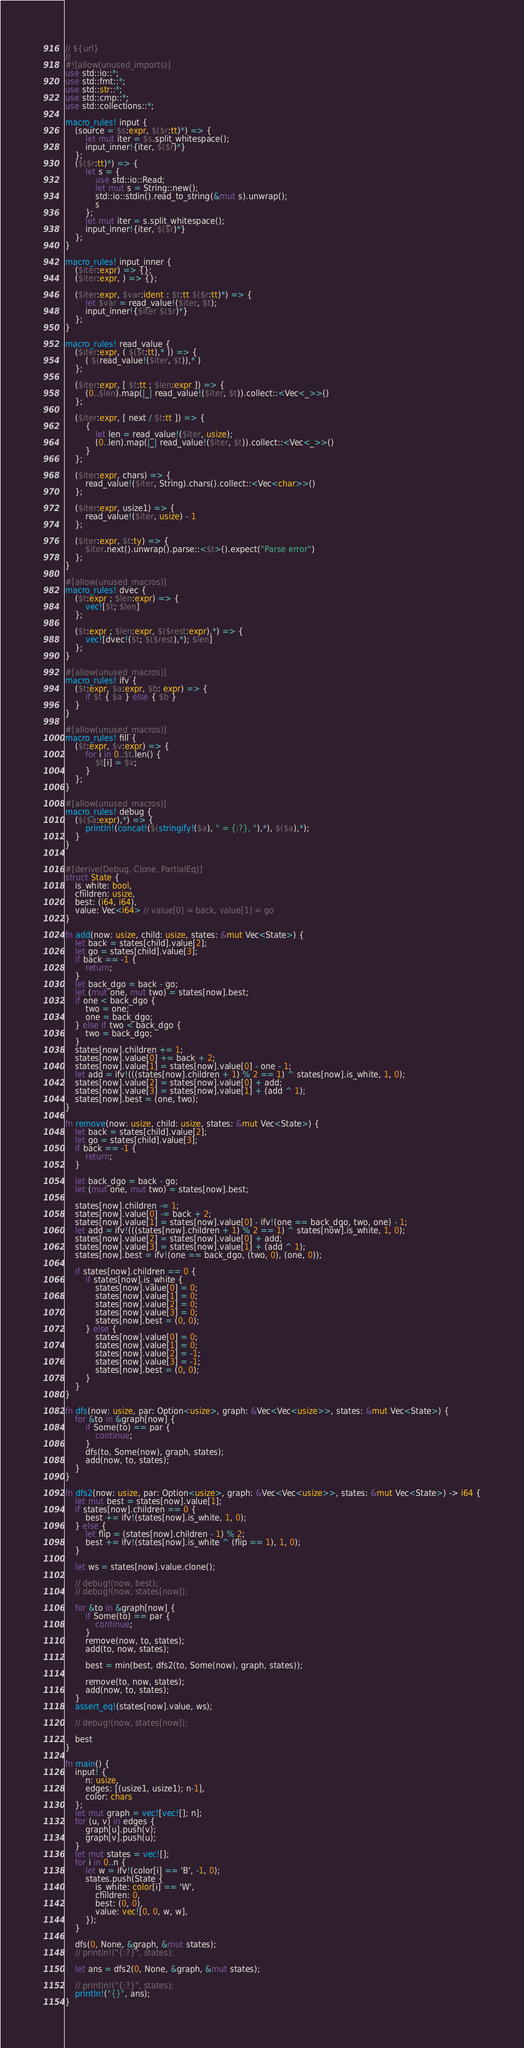<code> <loc_0><loc_0><loc_500><loc_500><_Rust_>// ${url}
//
#![allow(unused_imports)]
use std::io::*;
use std::fmt::*;
use std::str::*;
use std::cmp::*;
use std::collections::*;

macro_rules! input {
    (source = $s:expr, $($r:tt)*) => {
        let mut iter = $s.split_whitespace();
        input_inner!{iter, $($r)*}
    };
    ($($r:tt)*) => {
        let s = {
            use std::io::Read;
            let mut s = String::new();
            std::io::stdin().read_to_string(&mut s).unwrap();
            s
        };
        let mut iter = s.split_whitespace();
        input_inner!{iter, $($r)*}
    };
}

macro_rules! input_inner {
    ($iter:expr) => {};
    ($iter:expr, ) => {};

    ($iter:expr, $var:ident : $t:tt $($r:tt)*) => {
        let $var = read_value!($iter, $t);
        input_inner!{$iter $($r)*}
    };
}

macro_rules! read_value {
    ($iter:expr, ( $($t:tt),* )) => {
        ( $(read_value!($iter, $t)),* )
    };

    ($iter:expr, [ $t:tt ; $len:expr ]) => {
        (0..$len).map(|_| read_value!($iter, $t)).collect::<Vec<_>>()
    };

    ($iter:expr, [ next / $t:tt ]) => {
        {
            let len = read_value!($iter, usize);
            (0..len).map(|_| read_value!($iter, $t)).collect::<Vec<_>>()
        }
    };

    ($iter:expr, chars) => {
        read_value!($iter, String).chars().collect::<Vec<char>>()
    };

    ($iter:expr, usize1) => {
        read_value!($iter, usize) - 1
    };

    ($iter:expr, $t:ty) => {
        $iter.next().unwrap().parse::<$t>().expect("Parse error")
    };
}

#[allow(unused_macros)]
macro_rules! dvec {
    ($t:expr ; $len:expr) => {
        vec![$t; $len]
    };

    ($t:expr ; $len:expr, $($rest:expr),*) => {
        vec![dvec!($t; $($rest),*); $len]
    };
}

#[allow(unused_macros)]
macro_rules! ifv {
    ($t:expr, $a:expr, $b: expr) => {
        if $t { $a } else { $b }
    }
}

#[allow(unused_macros)]
macro_rules! fill {
    ($t:expr, $v:expr) => {
        for i in 0..$t.len() {
            $t[i] = $v;
        }
    };
}

#[allow(unused_macros)]
macro_rules! debug {
    ($($a:expr),*) => {
        println!(concat!($(stringify!($a), " = {:?}, "),*), $($a),*);
    }
}


#[derive(Debug, Clone, PartialEq)]
struct State {
    is_white: bool,
    children: usize,
    best: (i64, i64),
    value: Vec<i64> // value[0] = back, value[1] = go
}

fn add(now: usize, child: usize, states: &mut Vec<State>) {
    let back = states[child].value[2];
    let go = states[child].value[3];
    if back == -1 {
        return;
    }
    let back_dgo = back - go;
    let (mut one, mut two) = states[now].best;
    if one < back_dgo {
        two = one;
        one = back_dgo;
    } else if two < back_dgo {
        two = back_dgo;
    }
    states[now].children += 1;
    states[now].value[0] += back + 2;
    states[now].value[1] = states[now].value[0] - one - 1;
    let add = ifv!(((states[now].children + 1) % 2 == 1) ^ states[now].is_white, 1, 0);
    states[now].value[2] = states[now].value[0] + add;
    states[now].value[3] = states[now].value[1] + (add ^ 1);
    states[now].best = (one, two);
}

fn remove(now: usize, child: usize, states: &mut Vec<State>) {
    let back = states[child].value[2];
    let go = states[child].value[3];
    if back == -1 {
        return;
    }

    let back_dgo = back - go;
    let (mut one, mut two) = states[now].best;

    states[now].children -= 1;
    states[now].value[0] -= back + 2;
    states[now].value[1] = states[now].value[0] - ifv!(one == back_dgo, two, one) - 1;
    let add = ifv!(((states[now].children + 1) % 2 == 1) ^ states[now].is_white, 1, 0);
    states[now].value[2] = states[now].value[0] + add;
    states[now].value[3] = states[now].value[1] + (add ^ 1);
    states[now].best = ifv!(one == back_dgo, (two, 0), (one, 0));

    if states[now].children == 0 {
        if states[now].is_white {
            states[now].value[0] = 0;
            states[now].value[1] = 0;
            states[now].value[2] = 0;
            states[now].value[3] = 0;
            states[now].best = (0, 0);
        } else {
            states[now].value[0] = 0;
            states[now].value[1] = 0;
            states[now].value[2] = -1;
            states[now].value[3] = -1;
            states[now].best = (0, 0);
        }
    }
}

fn dfs(now: usize, par: Option<usize>, graph: &Vec<Vec<usize>>, states: &mut Vec<State>) {
    for &to in &graph[now] {
        if Some(to) == par {
            continue;
        }
        dfs(to, Some(now), graph, states);
        add(now, to, states);
    }
}

fn dfs2(now: usize, par: Option<usize>, graph: &Vec<Vec<usize>>, states: &mut Vec<State>) -> i64 {
    let mut best = states[now].value[1];
    if states[now].children == 0 {
        best += ifv!(states[now].is_white, 1, 0);
    } else {
        let flip = (states[now].children - 1) % 2;
        best += ifv!(states[now].is_white ^ (flip == 1), 1, 0);
    }

    let ws = states[now].value.clone();

    // debug!(now, best);
    // debug!(now, states[now]);

    for &to in &graph[now] {
        if Some(to) == par {
            continue;
        }
        remove(now, to, states);
        add(to, now, states);

        best = min(best, dfs2(to, Some(now), graph, states));

        remove(to, now, states);
        add(now, to, states);
    }
    assert_eq!(states[now].value, ws);

    // debug!(now, states[now]);

    best
}

fn main() {
    input! {
        n: usize,
        edges: [(usize1, usize1); n-1],
        color: chars
    };
    let mut graph = vec![vec![]; n];
    for (u, v) in edges {
        graph[u].push(v);
        graph[v].push(u);
    }
    let mut states = vec![];
    for i in 0..n {
        let w = ifv!(color[i] == 'B', -1, 0);
        states.push(State {
            is_white: color[i] == 'W',
            children: 0,
            best: (0, 0),
            value: vec![0, 0, w, w],
        });
    }

    dfs(0, None, &graph, &mut states);
    // println!("{:?}", states);

    let ans = dfs2(0, None, &graph, &mut states);

    // println!("{:?}", states);
    println!("{}", ans);
}
</code> 